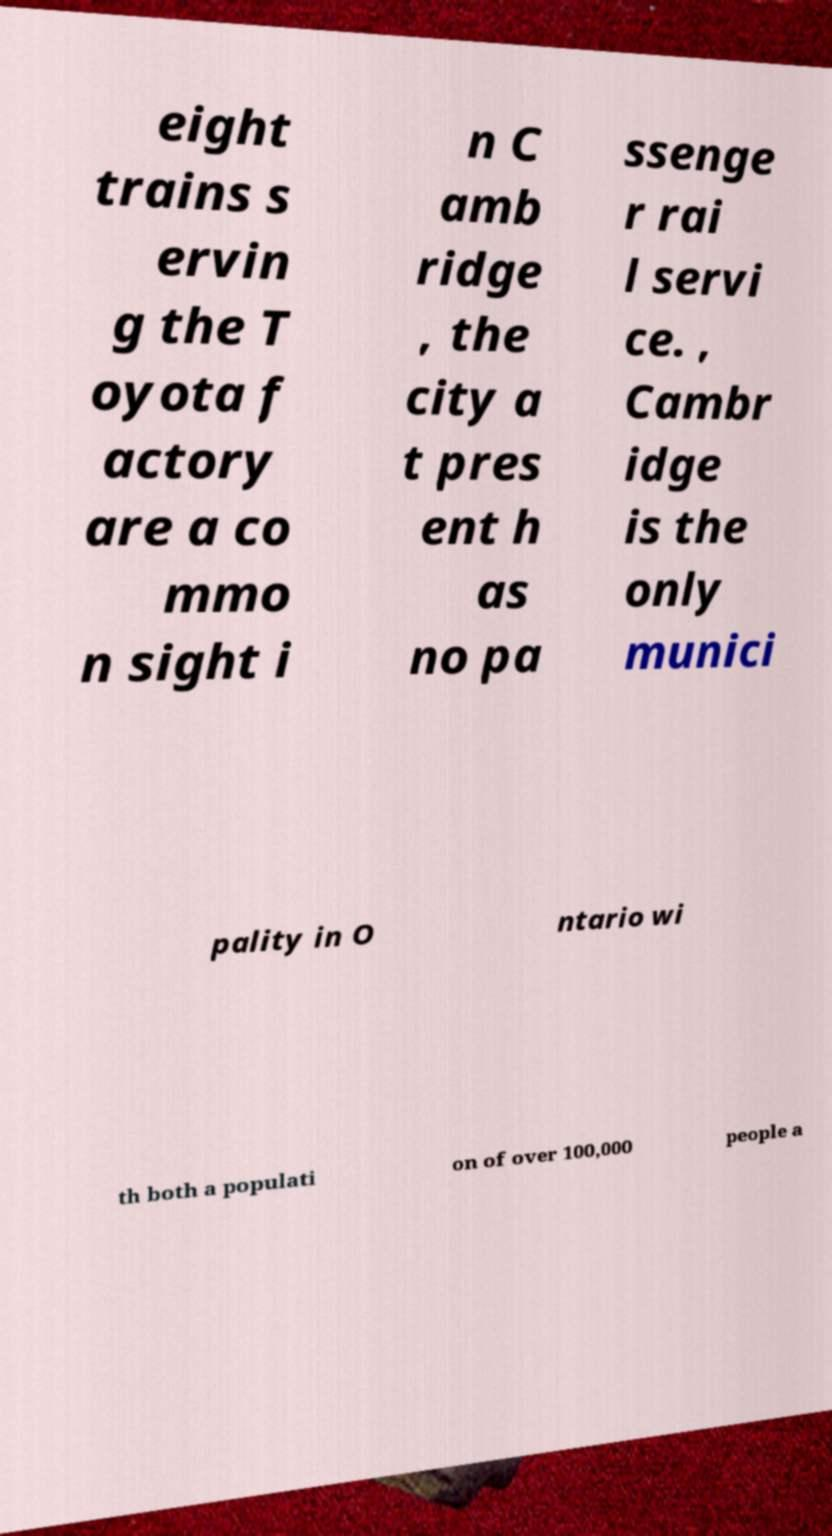Can you read and provide the text displayed in the image?This photo seems to have some interesting text. Can you extract and type it out for me? eight trains s ervin g the T oyota f actory are a co mmo n sight i n C amb ridge , the city a t pres ent h as no pa ssenge r rai l servi ce. , Cambr idge is the only munici pality in O ntario wi th both a populati on of over 100,000 people a 